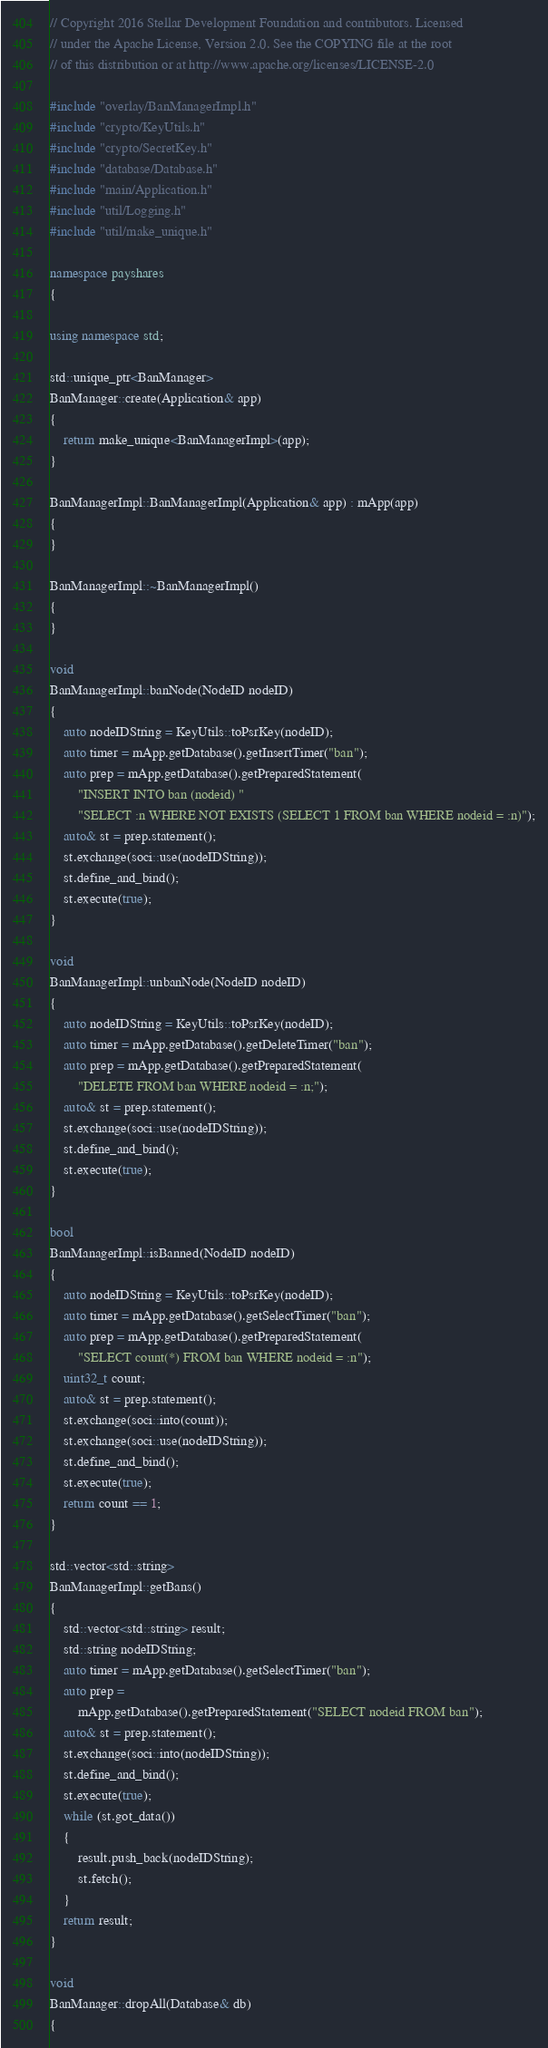<code> <loc_0><loc_0><loc_500><loc_500><_C++_>// Copyright 2016 Stellar Development Foundation and contributors. Licensed
// under the Apache License, Version 2.0. See the COPYING file at the root
// of this distribution or at http://www.apache.org/licenses/LICENSE-2.0

#include "overlay/BanManagerImpl.h"
#include "crypto/KeyUtils.h"
#include "crypto/SecretKey.h"
#include "database/Database.h"
#include "main/Application.h"
#include "util/Logging.h"
#include "util/make_unique.h"

namespace payshares
{

using namespace std;

std::unique_ptr<BanManager>
BanManager::create(Application& app)
{
    return make_unique<BanManagerImpl>(app);
}

BanManagerImpl::BanManagerImpl(Application& app) : mApp(app)
{
}

BanManagerImpl::~BanManagerImpl()
{
}

void
BanManagerImpl::banNode(NodeID nodeID)
{
    auto nodeIDString = KeyUtils::toPsrKey(nodeID);
    auto timer = mApp.getDatabase().getInsertTimer("ban");
    auto prep = mApp.getDatabase().getPreparedStatement(
        "INSERT INTO ban (nodeid) "
        "SELECT :n WHERE NOT EXISTS (SELECT 1 FROM ban WHERE nodeid = :n)");
    auto& st = prep.statement();
    st.exchange(soci::use(nodeIDString));
    st.define_and_bind();
    st.execute(true);
}

void
BanManagerImpl::unbanNode(NodeID nodeID)
{
    auto nodeIDString = KeyUtils::toPsrKey(nodeID);
    auto timer = mApp.getDatabase().getDeleteTimer("ban");
    auto prep = mApp.getDatabase().getPreparedStatement(
        "DELETE FROM ban WHERE nodeid = :n;");
    auto& st = prep.statement();
    st.exchange(soci::use(nodeIDString));
    st.define_and_bind();
    st.execute(true);
}

bool
BanManagerImpl::isBanned(NodeID nodeID)
{
    auto nodeIDString = KeyUtils::toPsrKey(nodeID);
    auto timer = mApp.getDatabase().getSelectTimer("ban");
    auto prep = mApp.getDatabase().getPreparedStatement(
        "SELECT count(*) FROM ban WHERE nodeid = :n");
    uint32_t count;
    auto& st = prep.statement();
    st.exchange(soci::into(count));
    st.exchange(soci::use(nodeIDString));
    st.define_and_bind();
    st.execute(true);
    return count == 1;
}

std::vector<std::string>
BanManagerImpl::getBans()
{
    std::vector<std::string> result;
    std::string nodeIDString;
    auto timer = mApp.getDatabase().getSelectTimer("ban");
    auto prep =
        mApp.getDatabase().getPreparedStatement("SELECT nodeid FROM ban");
    auto& st = prep.statement();
    st.exchange(soci::into(nodeIDString));
    st.define_and_bind();
    st.execute(true);
    while (st.got_data())
    {
        result.push_back(nodeIDString);
        st.fetch();
    }
    return result;
}

void
BanManager::dropAll(Database& db)
{</code> 